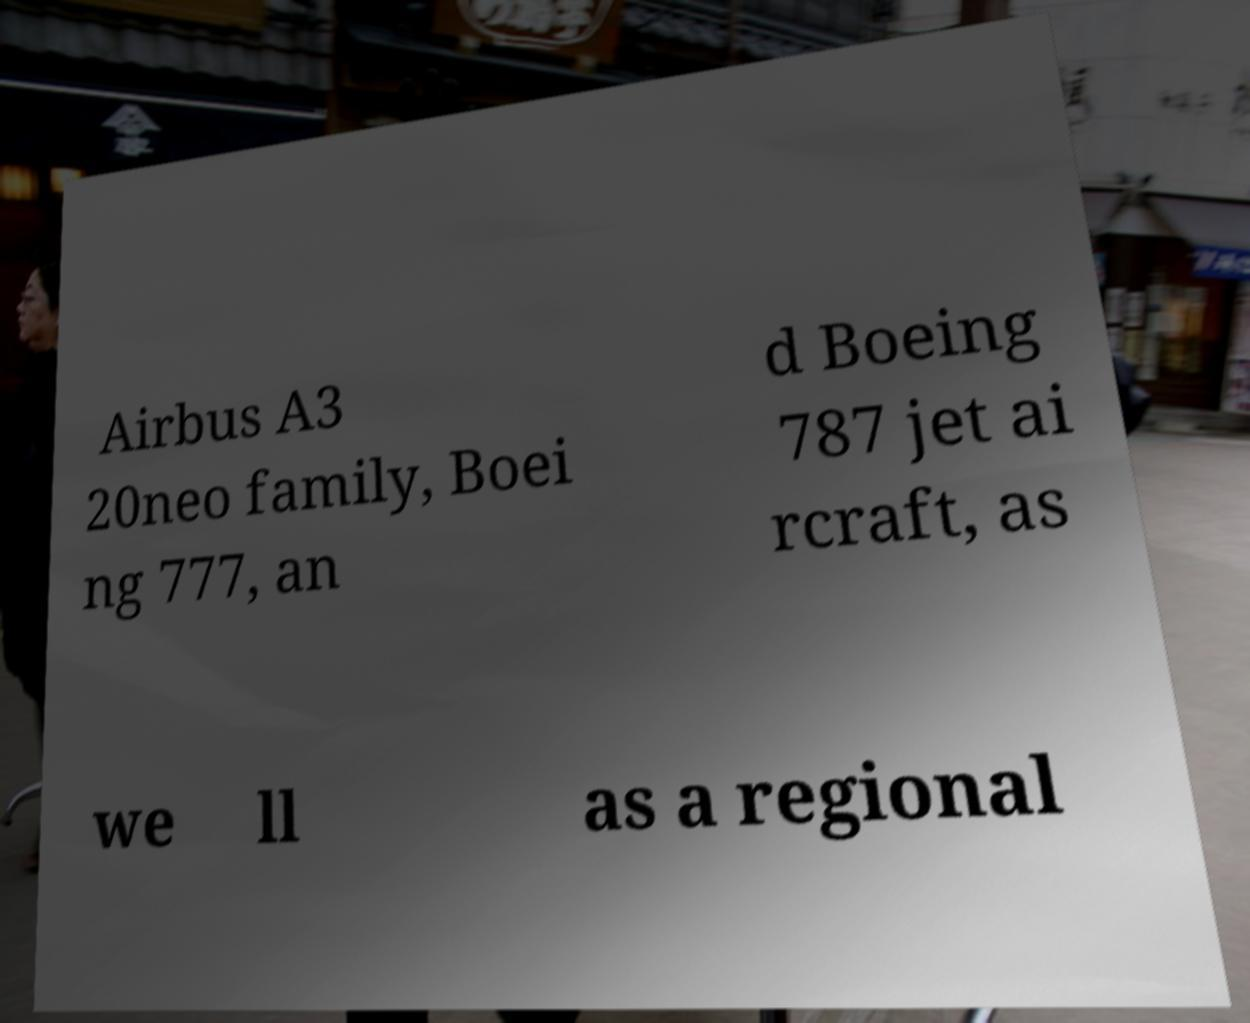There's text embedded in this image that I need extracted. Can you transcribe it verbatim? Airbus A3 20neo family, Boei ng 777, an d Boeing 787 jet ai rcraft, as we ll as a regional 